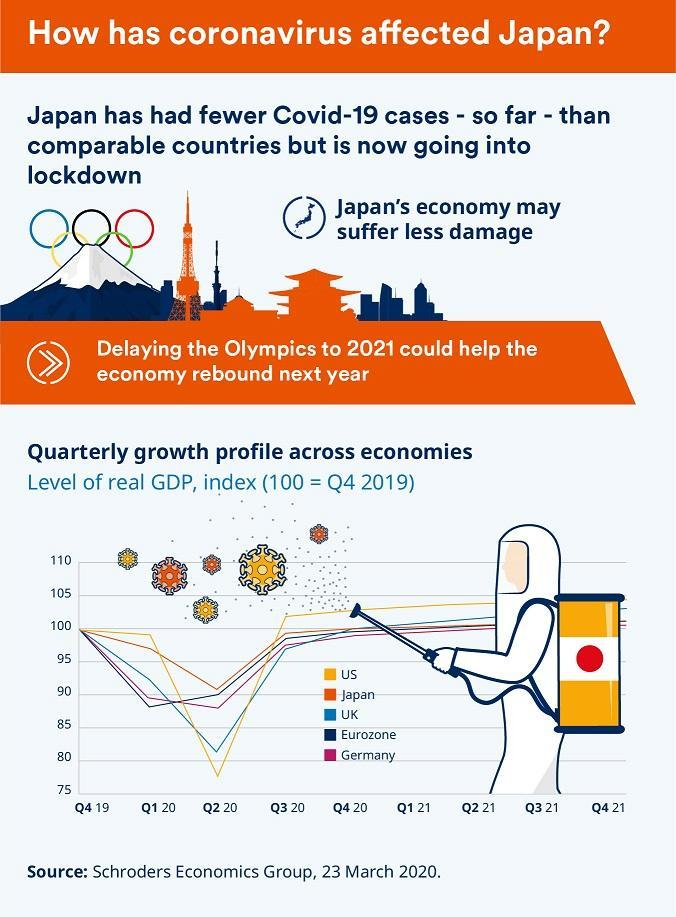Which region has the second highest GDP
Answer the question with a short phrase. Eurozone Which country has the second lowest GDP in Q2 20 UK Which country has a growth rate between Germany and US UK 